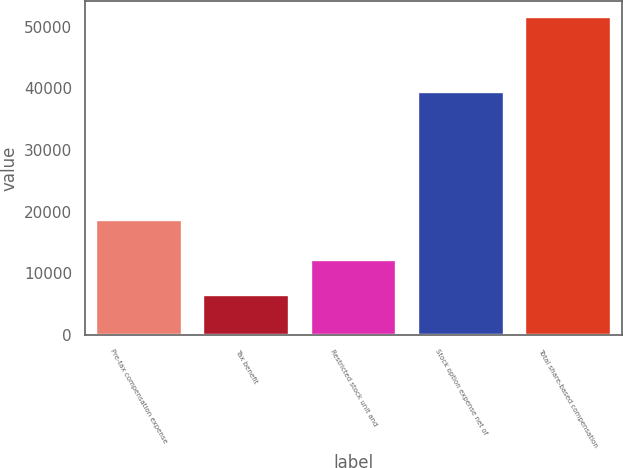Convert chart to OTSL. <chart><loc_0><loc_0><loc_500><loc_500><bar_chart><fcel>Pre-tax compensation expense<fcel>Tax benefit<fcel>Restricted stock unit and<fcel>Stock option expense net of<fcel>Total share-based compensation<nl><fcel>18708<fcel>6548<fcel>12160<fcel>39386<fcel>51546<nl></chart> 